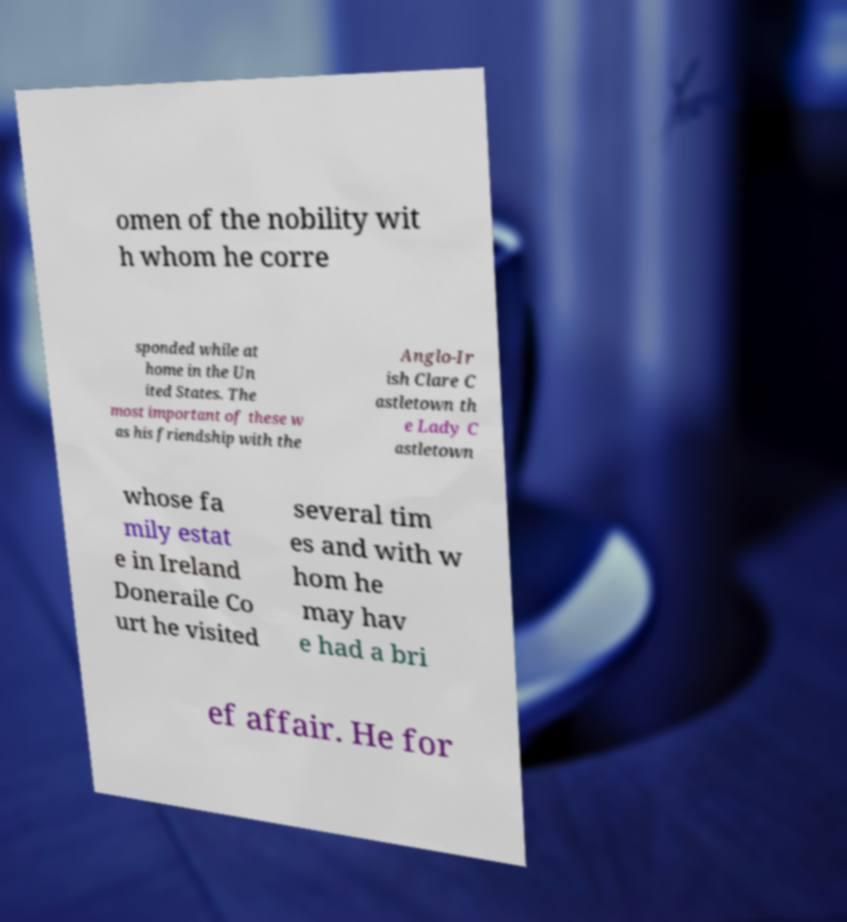Can you accurately transcribe the text from the provided image for me? omen of the nobility wit h whom he corre sponded while at home in the Un ited States. The most important of these w as his friendship with the Anglo-Ir ish Clare C astletown th e Lady C astletown whose fa mily estat e in Ireland Doneraile Co urt he visited several tim es and with w hom he may hav e had a bri ef affair. He for 